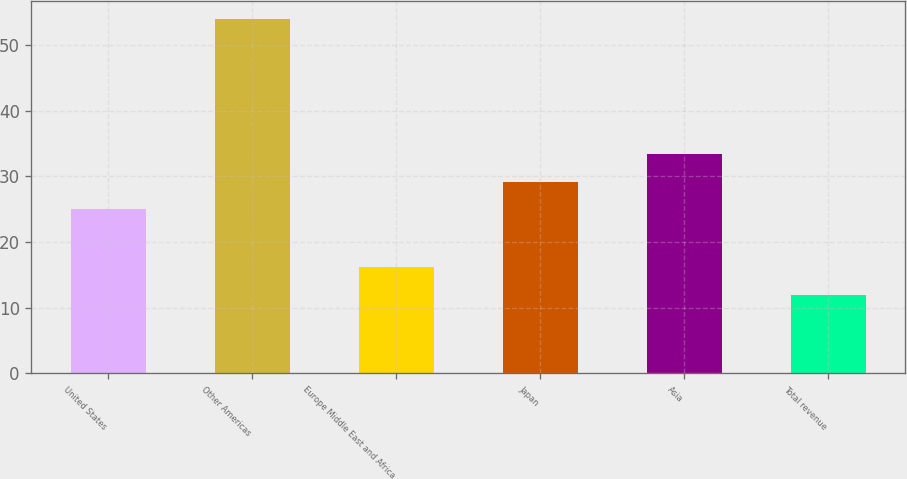Convert chart. <chart><loc_0><loc_0><loc_500><loc_500><bar_chart><fcel>United States<fcel>Other Americas<fcel>Europe Middle East and Africa<fcel>Japan<fcel>Asia<fcel>Total revenue<nl><fcel>25<fcel>54<fcel>16.2<fcel>29.2<fcel>33.4<fcel>12<nl></chart> 